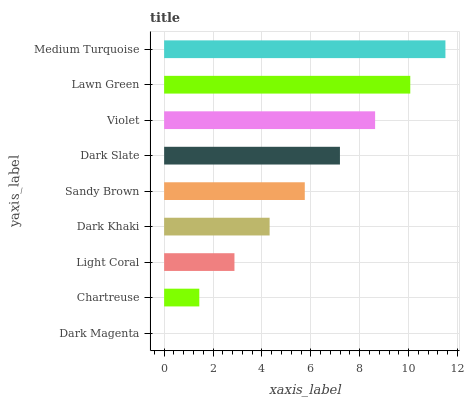Is Dark Magenta the minimum?
Answer yes or no. Yes. Is Medium Turquoise the maximum?
Answer yes or no. Yes. Is Chartreuse the minimum?
Answer yes or no. No. Is Chartreuse the maximum?
Answer yes or no. No. Is Chartreuse greater than Dark Magenta?
Answer yes or no. Yes. Is Dark Magenta less than Chartreuse?
Answer yes or no. Yes. Is Dark Magenta greater than Chartreuse?
Answer yes or no. No. Is Chartreuse less than Dark Magenta?
Answer yes or no. No. Is Sandy Brown the high median?
Answer yes or no. Yes. Is Sandy Brown the low median?
Answer yes or no. Yes. Is Light Coral the high median?
Answer yes or no. No. Is Dark Khaki the low median?
Answer yes or no. No. 